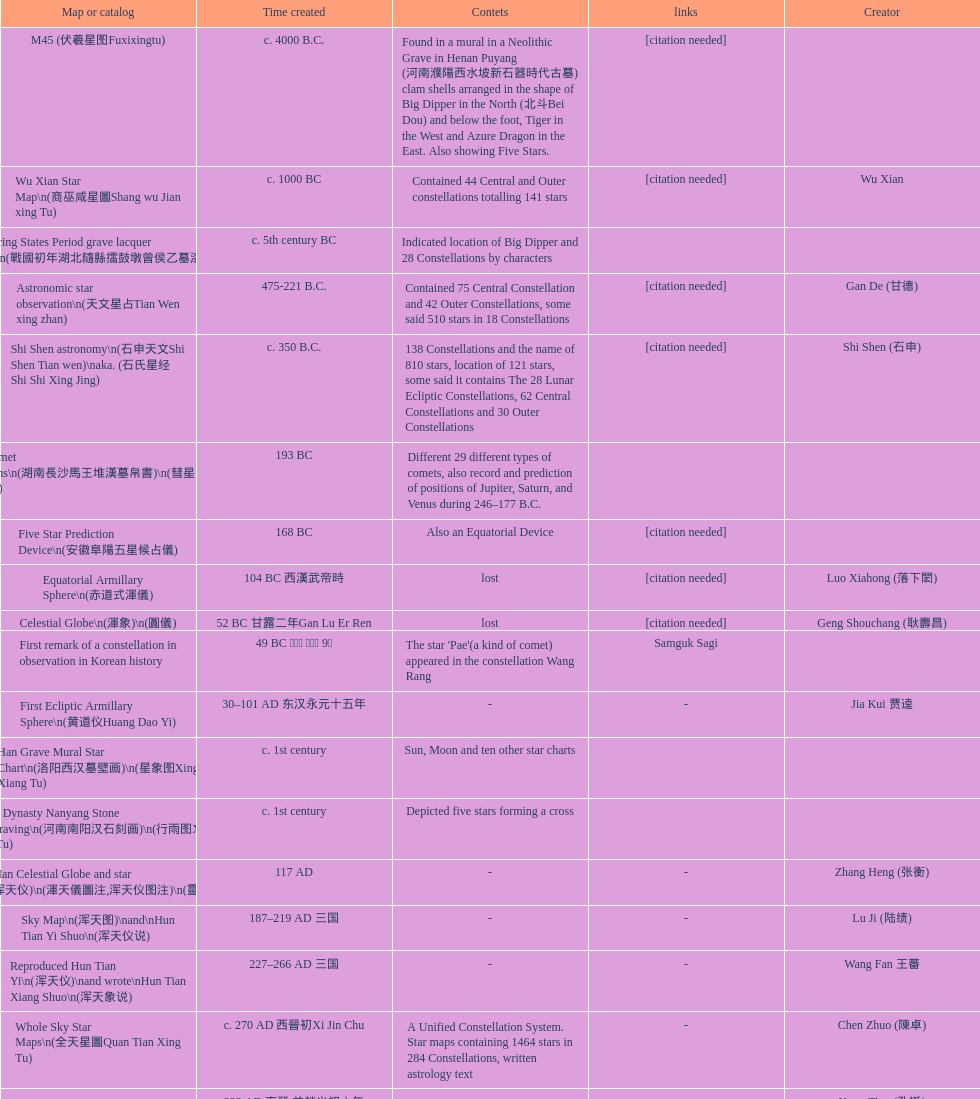Which was the first chinese star map known to have been created? M45 (伏羲星图Fuxixingtu). 